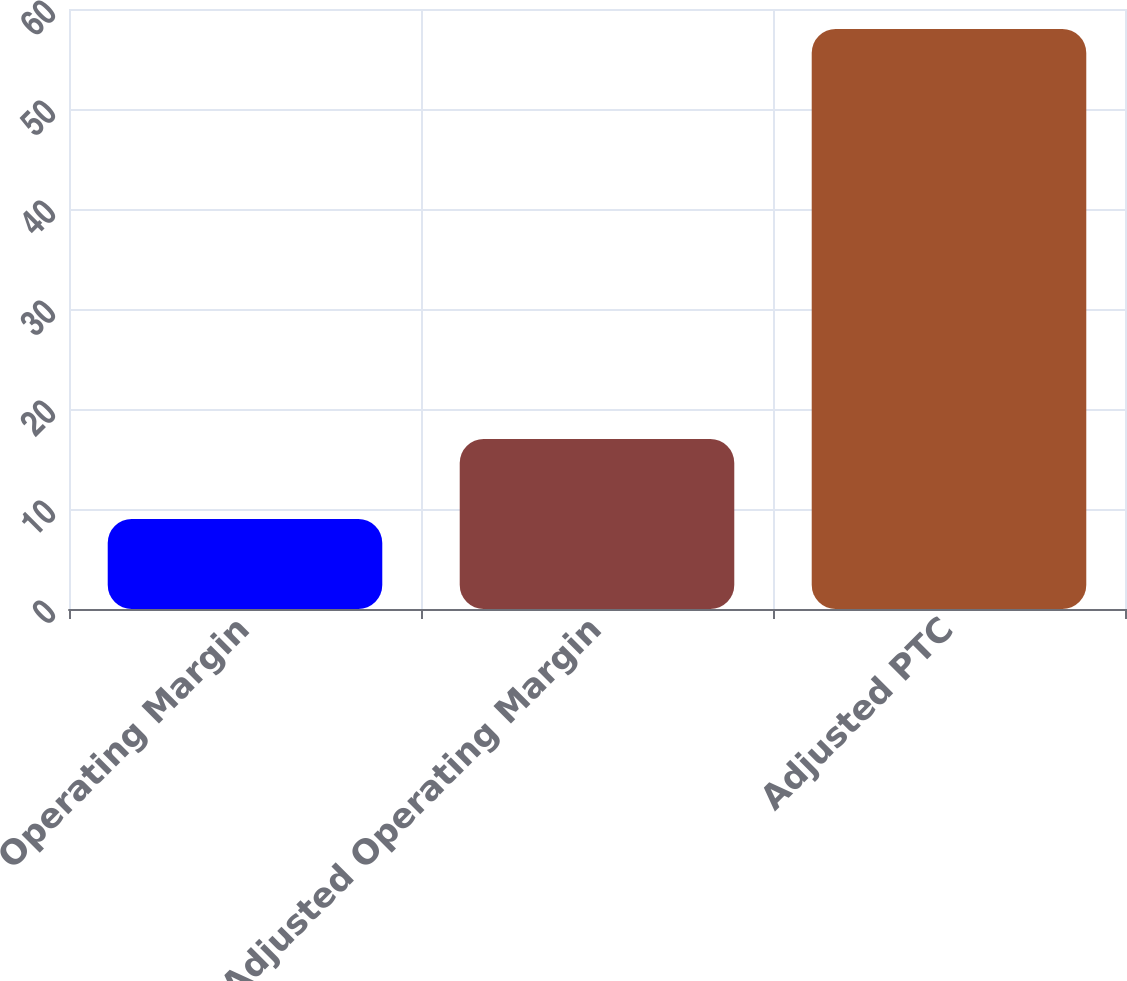Convert chart to OTSL. <chart><loc_0><loc_0><loc_500><loc_500><bar_chart><fcel>Operating Margin<fcel>Adjusted Operating Margin<fcel>Adjusted PTC<nl><fcel>9<fcel>17<fcel>58<nl></chart> 